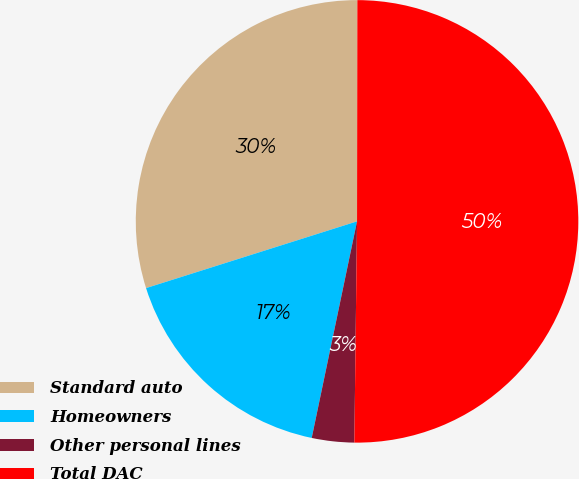<chart> <loc_0><loc_0><loc_500><loc_500><pie_chart><fcel>Standard auto<fcel>Homeowners<fcel>Other personal lines<fcel>Total DAC<nl><fcel>29.9%<fcel>16.84%<fcel>3.09%<fcel>50.17%<nl></chart> 